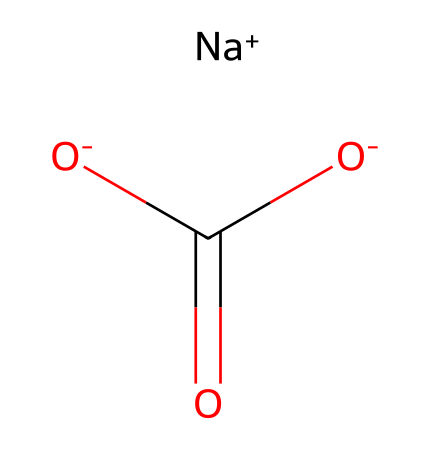What is the common name of this chemical? The SMILES representation corresponds to a compound known as sodium bicarbonate, commonly referred to as baking soda.
Answer: baking soda How many oxygen atoms are present in the structure? By analyzing the SMILES representation, we can count two oxygen atoms in the carboxylate group (–COO–) and one in the bicarbonate structure, totaling three oxygen atoms.
Answer: three What is the charge of the sodium ion in this compound? The SMILES notation indicates that sodium is depicted as [Na+], signifying a positive charge on the sodium ion.
Answer: positive What type of bond connects the sodium ion to the bicarbonate ion? The sodium ion is held together with the bicarbonate ion by an ionic bond due to the charge difference, as indicated by their respective symbols ([Na+] and [O-] in the SMILES).
Answer: ionic bond How many hydrogen atoms are in this chemical compound? The chemical representation suggests there is one hydrogen atom attached to the bicarbonate ion (–HCO3) since bicarbonate consists of one hydrogen in its formula.
Answer: one Is this compound soluble in water? Sodium bicarbonate is known to be water-soluble, which can be inferred from its ionic nature as a salt.
Answer: yes What is the general acidity of this compound? Sodium bicarbonate displays weakly basic properties since it acts as a buffer, maintaining a neutral pH when dissolved in water.
Answer: basic 